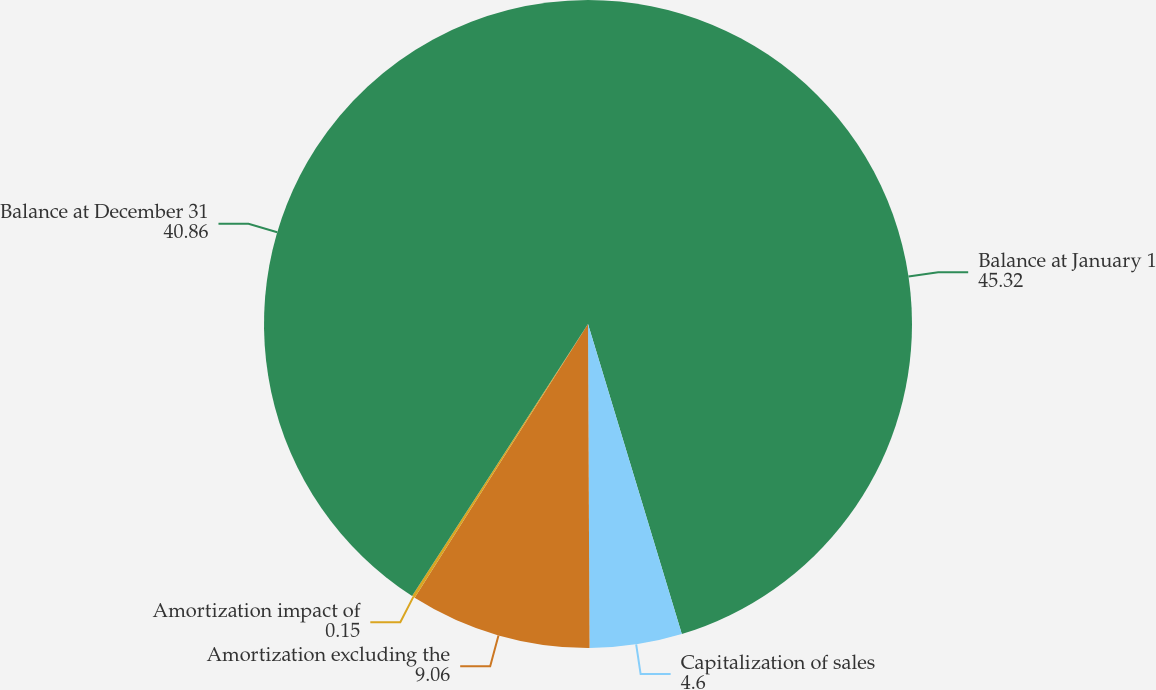Convert chart to OTSL. <chart><loc_0><loc_0><loc_500><loc_500><pie_chart><fcel>Balance at January 1<fcel>Capitalization of sales<fcel>Amortization excluding the<fcel>Amortization impact of<fcel>Balance at December 31<nl><fcel>45.32%<fcel>4.6%<fcel>9.06%<fcel>0.15%<fcel>40.86%<nl></chart> 